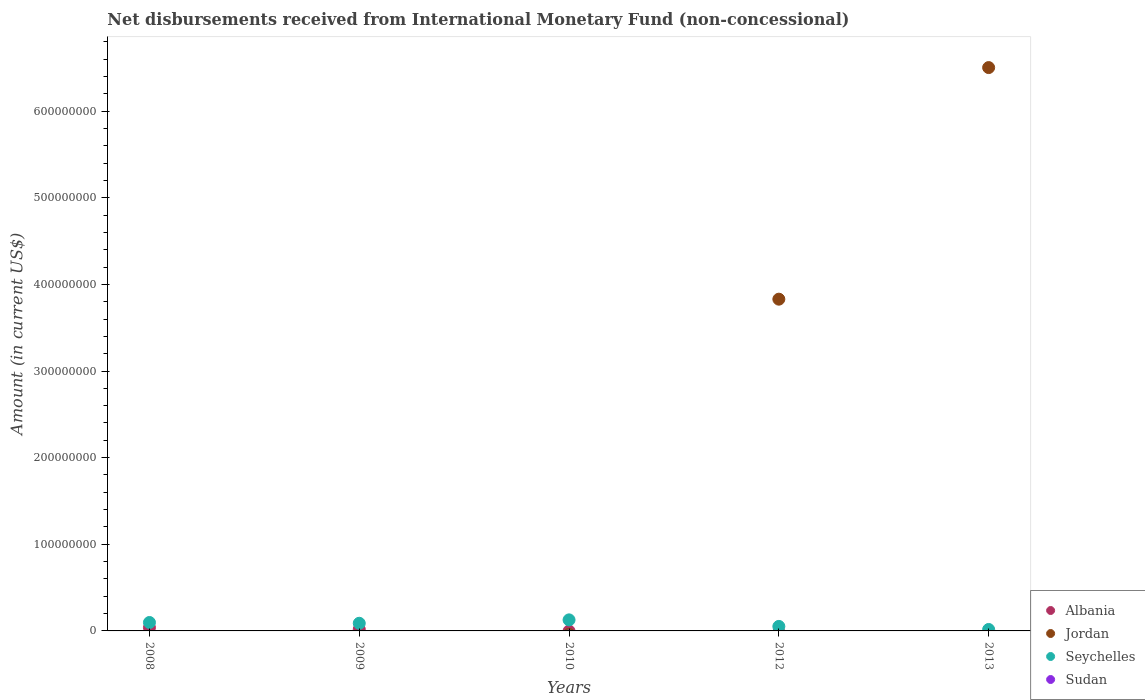How many different coloured dotlines are there?
Offer a very short reply. 3. Is the number of dotlines equal to the number of legend labels?
Keep it short and to the point. No. What is the amount of disbursements received from International Monetary Fund in Albania in 2010?
Offer a terse response. 0. Across all years, what is the maximum amount of disbursements received from International Monetary Fund in Jordan?
Provide a succinct answer. 6.50e+08. In which year was the amount of disbursements received from International Monetary Fund in Albania maximum?
Give a very brief answer. 2008. What is the total amount of disbursements received from International Monetary Fund in Sudan in the graph?
Make the answer very short. 0. What is the difference between the amount of disbursements received from International Monetary Fund in Jordan in 2012 and that in 2013?
Offer a terse response. -2.67e+08. What is the difference between the amount of disbursements received from International Monetary Fund in Albania in 2013 and the amount of disbursements received from International Monetary Fund in Jordan in 2012?
Keep it short and to the point. -3.83e+08. What is the average amount of disbursements received from International Monetary Fund in Seychelles per year?
Provide a short and direct response. 7.64e+06. In the year 2008, what is the difference between the amount of disbursements received from International Monetary Fund in Albania and amount of disbursements received from International Monetary Fund in Seychelles?
Make the answer very short. -5.89e+06. In how many years, is the amount of disbursements received from International Monetary Fund in Sudan greater than 500000000 US$?
Ensure brevity in your answer.  0. What is the ratio of the amount of disbursements received from International Monetary Fund in Seychelles in 2008 to that in 2009?
Ensure brevity in your answer.  1.1. Is the amount of disbursements received from International Monetary Fund in Seychelles in 2010 less than that in 2013?
Your response must be concise. No. Is the difference between the amount of disbursements received from International Monetary Fund in Albania in 2008 and 2009 greater than the difference between the amount of disbursements received from International Monetary Fund in Seychelles in 2008 and 2009?
Ensure brevity in your answer.  Yes. What is the difference between the highest and the second highest amount of disbursements received from International Monetary Fund in Seychelles?
Ensure brevity in your answer.  3.02e+06. What is the difference between the highest and the lowest amount of disbursements received from International Monetary Fund in Jordan?
Your response must be concise. 6.50e+08. Does the amount of disbursements received from International Monetary Fund in Jordan monotonically increase over the years?
Give a very brief answer. Yes. Is the amount of disbursements received from International Monetary Fund in Albania strictly less than the amount of disbursements received from International Monetary Fund in Jordan over the years?
Your answer should be very brief. No. Are the values on the major ticks of Y-axis written in scientific E-notation?
Provide a succinct answer. No. Does the graph contain any zero values?
Make the answer very short. Yes. Where does the legend appear in the graph?
Offer a terse response. Bottom right. What is the title of the graph?
Provide a short and direct response. Net disbursements received from International Monetary Fund (non-concessional). What is the Amount (in current US$) in Albania in 2008?
Provide a succinct answer. 3.85e+06. What is the Amount (in current US$) in Jordan in 2008?
Keep it short and to the point. 0. What is the Amount (in current US$) in Seychelles in 2008?
Ensure brevity in your answer.  9.74e+06. What is the Amount (in current US$) of Sudan in 2008?
Your answer should be very brief. 0. What is the Amount (in current US$) in Albania in 2009?
Provide a succinct answer. 1.88e+06. What is the Amount (in current US$) of Seychelles in 2009?
Ensure brevity in your answer.  8.82e+06. What is the Amount (in current US$) in Sudan in 2009?
Offer a very short reply. 0. What is the Amount (in current US$) in Albania in 2010?
Keep it short and to the point. 0. What is the Amount (in current US$) of Jordan in 2010?
Provide a succinct answer. 0. What is the Amount (in current US$) of Seychelles in 2010?
Keep it short and to the point. 1.28e+07. What is the Amount (in current US$) of Albania in 2012?
Ensure brevity in your answer.  0. What is the Amount (in current US$) in Jordan in 2012?
Offer a very short reply. 3.83e+08. What is the Amount (in current US$) of Seychelles in 2012?
Your answer should be very brief. 5.21e+06. What is the Amount (in current US$) of Jordan in 2013?
Offer a terse response. 6.50e+08. What is the Amount (in current US$) in Seychelles in 2013?
Offer a terse response. 1.68e+06. What is the Amount (in current US$) in Sudan in 2013?
Make the answer very short. 0. Across all years, what is the maximum Amount (in current US$) in Albania?
Provide a succinct answer. 3.85e+06. Across all years, what is the maximum Amount (in current US$) in Jordan?
Your response must be concise. 6.50e+08. Across all years, what is the maximum Amount (in current US$) in Seychelles?
Your answer should be very brief. 1.28e+07. Across all years, what is the minimum Amount (in current US$) of Albania?
Give a very brief answer. 0. Across all years, what is the minimum Amount (in current US$) of Jordan?
Keep it short and to the point. 0. Across all years, what is the minimum Amount (in current US$) of Seychelles?
Give a very brief answer. 1.68e+06. What is the total Amount (in current US$) of Albania in the graph?
Provide a short and direct response. 5.73e+06. What is the total Amount (in current US$) of Jordan in the graph?
Give a very brief answer. 1.03e+09. What is the total Amount (in current US$) of Seychelles in the graph?
Give a very brief answer. 3.82e+07. What is the total Amount (in current US$) in Sudan in the graph?
Keep it short and to the point. 0. What is the difference between the Amount (in current US$) in Albania in 2008 and that in 2009?
Make the answer very short. 1.97e+06. What is the difference between the Amount (in current US$) of Seychelles in 2008 and that in 2009?
Your answer should be compact. 9.14e+05. What is the difference between the Amount (in current US$) in Seychelles in 2008 and that in 2010?
Provide a short and direct response. -3.02e+06. What is the difference between the Amount (in current US$) in Seychelles in 2008 and that in 2012?
Give a very brief answer. 4.53e+06. What is the difference between the Amount (in current US$) of Seychelles in 2008 and that in 2013?
Your answer should be very brief. 8.06e+06. What is the difference between the Amount (in current US$) of Seychelles in 2009 and that in 2010?
Provide a succinct answer. -3.93e+06. What is the difference between the Amount (in current US$) in Seychelles in 2009 and that in 2012?
Provide a short and direct response. 3.61e+06. What is the difference between the Amount (in current US$) of Seychelles in 2009 and that in 2013?
Offer a terse response. 7.14e+06. What is the difference between the Amount (in current US$) of Seychelles in 2010 and that in 2012?
Give a very brief answer. 7.55e+06. What is the difference between the Amount (in current US$) in Seychelles in 2010 and that in 2013?
Keep it short and to the point. 1.11e+07. What is the difference between the Amount (in current US$) in Jordan in 2012 and that in 2013?
Provide a succinct answer. -2.67e+08. What is the difference between the Amount (in current US$) in Seychelles in 2012 and that in 2013?
Give a very brief answer. 3.53e+06. What is the difference between the Amount (in current US$) of Albania in 2008 and the Amount (in current US$) of Seychelles in 2009?
Your answer should be very brief. -4.97e+06. What is the difference between the Amount (in current US$) of Albania in 2008 and the Amount (in current US$) of Seychelles in 2010?
Your response must be concise. -8.91e+06. What is the difference between the Amount (in current US$) of Albania in 2008 and the Amount (in current US$) of Jordan in 2012?
Provide a short and direct response. -3.79e+08. What is the difference between the Amount (in current US$) in Albania in 2008 and the Amount (in current US$) in Seychelles in 2012?
Offer a very short reply. -1.36e+06. What is the difference between the Amount (in current US$) of Albania in 2008 and the Amount (in current US$) of Jordan in 2013?
Offer a very short reply. -6.46e+08. What is the difference between the Amount (in current US$) of Albania in 2008 and the Amount (in current US$) of Seychelles in 2013?
Provide a short and direct response. 2.17e+06. What is the difference between the Amount (in current US$) in Albania in 2009 and the Amount (in current US$) in Seychelles in 2010?
Offer a terse response. -1.09e+07. What is the difference between the Amount (in current US$) in Albania in 2009 and the Amount (in current US$) in Jordan in 2012?
Offer a terse response. -3.81e+08. What is the difference between the Amount (in current US$) of Albania in 2009 and the Amount (in current US$) of Seychelles in 2012?
Make the answer very short. -3.33e+06. What is the difference between the Amount (in current US$) in Albania in 2009 and the Amount (in current US$) in Jordan in 2013?
Offer a very short reply. -6.48e+08. What is the difference between the Amount (in current US$) of Albania in 2009 and the Amount (in current US$) of Seychelles in 2013?
Give a very brief answer. 2.01e+05. What is the difference between the Amount (in current US$) in Jordan in 2012 and the Amount (in current US$) in Seychelles in 2013?
Ensure brevity in your answer.  3.81e+08. What is the average Amount (in current US$) in Albania per year?
Keep it short and to the point. 1.15e+06. What is the average Amount (in current US$) of Jordan per year?
Ensure brevity in your answer.  2.07e+08. What is the average Amount (in current US$) in Seychelles per year?
Offer a terse response. 7.64e+06. In the year 2008, what is the difference between the Amount (in current US$) of Albania and Amount (in current US$) of Seychelles?
Make the answer very short. -5.89e+06. In the year 2009, what is the difference between the Amount (in current US$) in Albania and Amount (in current US$) in Seychelles?
Offer a very short reply. -6.94e+06. In the year 2012, what is the difference between the Amount (in current US$) in Jordan and Amount (in current US$) in Seychelles?
Ensure brevity in your answer.  3.78e+08. In the year 2013, what is the difference between the Amount (in current US$) of Jordan and Amount (in current US$) of Seychelles?
Give a very brief answer. 6.49e+08. What is the ratio of the Amount (in current US$) in Albania in 2008 to that in 2009?
Provide a succinct answer. 2.05. What is the ratio of the Amount (in current US$) of Seychelles in 2008 to that in 2009?
Provide a succinct answer. 1.1. What is the ratio of the Amount (in current US$) of Seychelles in 2008 to that in 2010?
Provide a short and direct response. 0.76. What is the ratio of the Amount (in current US$) of Seychelles in 2008 to that in 2012?
Offer a very short reply. 1.87. What is the ratio of the Amount (in current US$) in Seychelles in 2008 to that in 2013?
Your response must be concise. 5.8. What is the ratio of the Amount (in current US$) in Seychelles in 2009 to that in 2010?
Provide a succinct answer. 0.69. What is the ratio of the Amount (in current US$) in Seychelles in 2009 to that in 2012?
Give a very brief answer. 1.69. What is the ratio of the Amount (in current US$) of Seychelles in 2009 to that in 2013?
Your response must be concise. 5.26. What is the ratio of the Amount (in current US$) of Seychelles in 2010 to that in 2012?
Your response must be concise. 2.45. What is the ratio of the Amount (in current US$) in Seychelles in 2010 to that in 2013?
Give a very brief answer. 7.6. What is the ratio of the Amount (in current US$) in Jordan in 2012 to that in 2013?
Provide a succinct answer. 0.59. What is the ratio of the Amount (in current US$) of Seychelles in 2012 to that in 2013?
Offer a terse response. 3.1. What is the difference between the highest and the second highest Amount (in current US$) of Seychelles?
Offer a terse response. 3.02e+06. What is the difference between the highest and the lowest Amount (in current US$) of Albania?
Your answer should be very brief. 3.85e+06. What is the difference between the highest and the lowest Amount (in current US$) of Jordan?
Give a very brief answer. 6.50e+08. What is the difference between the highest and the lowest Amount (in current US$) of Seychelles?
Keep it short and to the point. 1.11e+07. 